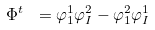Convert formula to latex. <formula><loc_0><loc_0><loc_500><loc_500>\Phi ^ { t } \ = \varphi _ { 1 } ^ { 1 } \varphi _ { I } ^ { 2 } - \varphi _ { 1 } ^ { 2 } \varphi _ { I } ^ { 1 }</formula> 